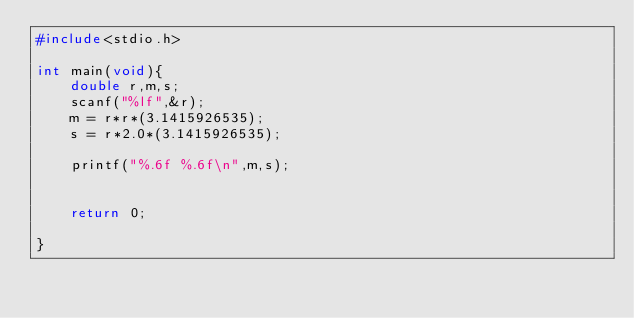<code> <loc_0><loc_0><loc_500><loc_500><_C_>#include<stdio.h>

int main(void){
	double r,m,s;
	scanf("%lf",&r);
	m = r*r*(3.1415926535);
	s = r*2.0*(3.1415926535);
	
	printf("%.6f %.6f\n",m,s);
	
	
	return 0;
	
}</code> 